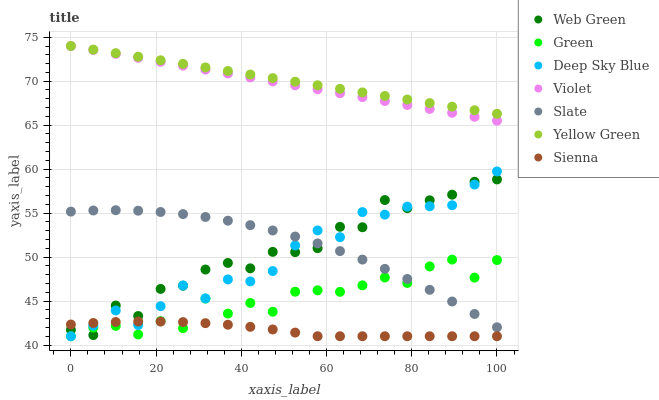Does Sienna have the minimum area under the curve?
Answer yes or no. Yes. Does Yellow Green have the maximum area under the curve?
Answer yes or no. Yes. Does Slate have the minimum area under the curve?
Answer yes or no. No. Does Slate have the maximum area under the curve?
Answer yes or no. No. Is Yellow Green the smoothest?
Answer yes or no. Yes. Is Web Green the roughest?
Answer yes or no. Yes. Is Slate the smoothest?
Answer yes or no. No. Is Slate the roughest?
Answer yes or no. No. Does Sienna have the lowest value?
Answer yes or no. Yes. Does Slate have the lowest value?
Answer yes or no. No. Does Violet have the highest value?
Answer yes or no. Yes. Does Slate have the highest value?
Answer yes or no. No. Is Sienna less than Yellow Green?
Answer yes or no. Yes. Is Yellow Green greater than Web Green?
Answer yes or no. Yes. Does Green intersect Sienna?
Answer yes or no. Yes. Is Green less than Sienna?
Answer yes or no. No. Is Green greater than Sienna?
Answer yes or no. No. Does Sienna intersect Yellow Green?
Answer yes or no. No. 